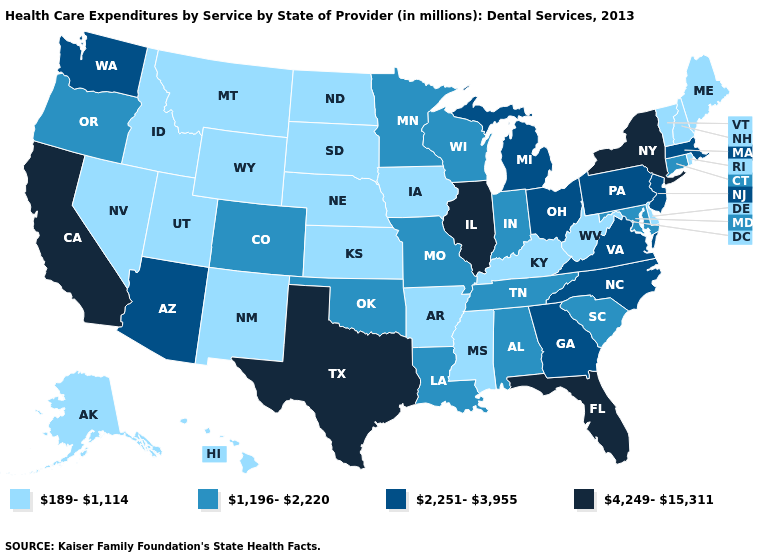Does Ohio have the highest value in the USA?
Write a very short answer. No. Does Kansas have the same value as Maine?
Short answer required. Yes. Among the states that border Florida , which have the lowest value?
Write a very short answer. Alabama. Does New Jersey have the highest value in the Northeast?
Answer briefly. No. Name the states that have a value in the range 4,249-15,311?
Keep it brief. California, Florida, Illinois, New York, Texas. What is the value of Alaska?
Write a very short answer. 189-1,114. Name the states that have a value in the range 4,249-15,311?
Answer briefly. California, Florida, Illinois, New York, Texas. What is the value of Connecticut?
Concise answer only. 1,196-2,220. What is the value of New York?
Concise answer only. 4,249-15,311. Which states have the lowest value in the Northeast?
Concise answer only. Maine, New Hampshire, Rhode Island, Vermont. Does Missouri have a higher value than Delaware?
Keep it brief. Yes. Name the states that have a value in the range 1,196-2,220?
Answer briefly. Alabama, Colorado, Connecticut, Indiana, Louisiana, Maryland, Minnesota, Missouri, Oklahoma, Oregon, South Carolina, Tennessee, Wisconsin. Is the legend a continuous bar?
Write a very short answer. No. Does the first symbol in the legend represent the smallest category?
Give a very brief answer. Yes. What is the value of Indiana?
Short answer required. 1,196-2,220. 